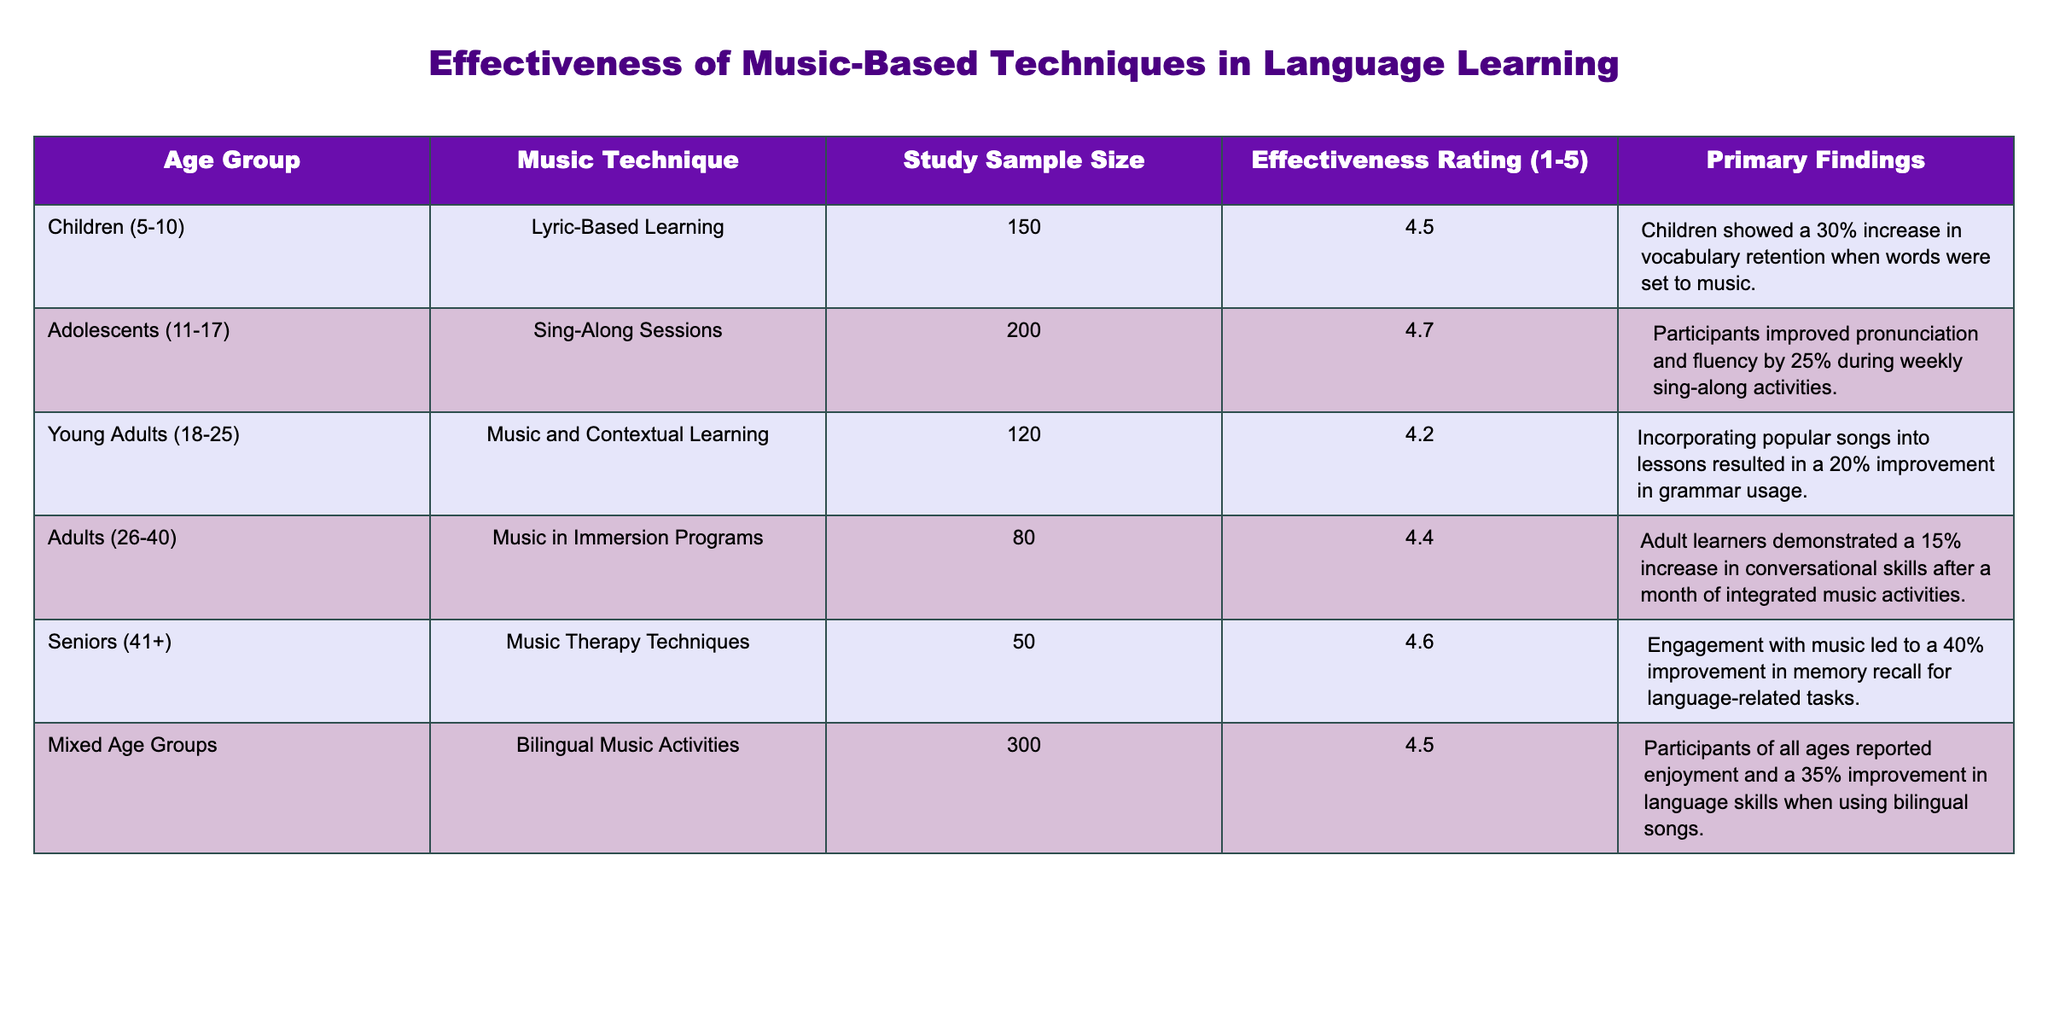What is the effectiveness rating for lyric-based learning in children? The effectiveness rating for lyric-based learning in children is directly available in the table under the "Effectiveness Rating (1-5)" column for the "Children (5-10)" age group, which is 4.5.
Answer: 4.5 Which music technique had the highest effectiveness rating? In the table, we check the "Effectiveness Rating (1-5)" for all the music techniques. The highest rating is 4.7 for "Sing-Along Sessions" with adolescents (11-17).
Answer: 4.7 What is the difference in sample size between the mixed age groups and young adults? To find the difference, we look at the "Study Sample Size" for mixed age groups (300) and young adults (120). We calculate the difference as 300 - 120 = 180.
Answer: 180 Did seniors show improvement in memory recall through music therapy techniques? According to the table, seniors (41+) had an effectiveness rating of 4.6 for music therapy techniques, which indicates that they did show improvement. Therefore, the answer is yes.
Answer: Yes What is the average effectiveness rating across all age groups listed? To find the average, we sum all the effectiveness ratings: (4.5 + 4.7 + 4.2 + 4.4 + 4.6 + 4.5) = 26.9. There are 6 age groups, so we divide by 6: 26.9 / 6 = approximately 4.48.
Answer: 4.48 Which age group showed the greatest improvement in conversational skills with music in immersion programs? By examining the table, the adults (26-40) using music in immersion programs showed a 15% increase in conversational skills, as noted in the primary findings of their respective row.
Answer: Adults (26-40) How many more participants were involved in the mixed age groups than in seniors? We compare the "Study Sample Size" for mixed age groups (300) and seniors (50). The calculation shows that 300 - 50 = 250 more participants were in the mixed age groups.
Answer: 250 Was there a significant increase in vocabulary retention for children using lyric-based learning methods? The effect of lyric-based learning for children resulted in a 30% increase in vocabulary retention, indicated in the primary findings, suggesting a significant improvement. Therefore, the answer is yes.
Answer: Yes What effect did music and contextual learning have on young adults’ grammar usage? According to the primary findings for "Music and Contextual Learning" with young adults (18-25), there was a 20% improvement in grammar usage, which shows a positive effect.
Answer: 20% improvement 